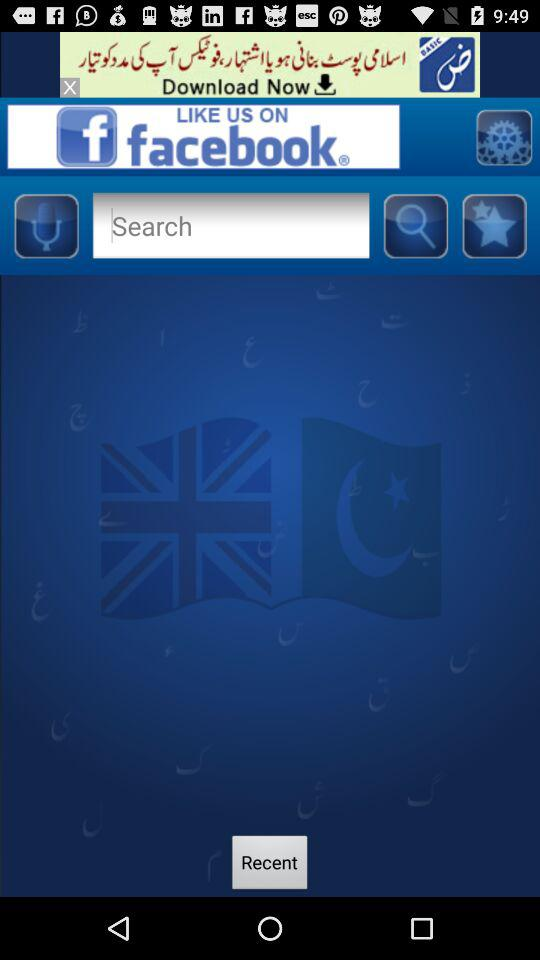On what account can I like the application? You can like the application on "facebook". 